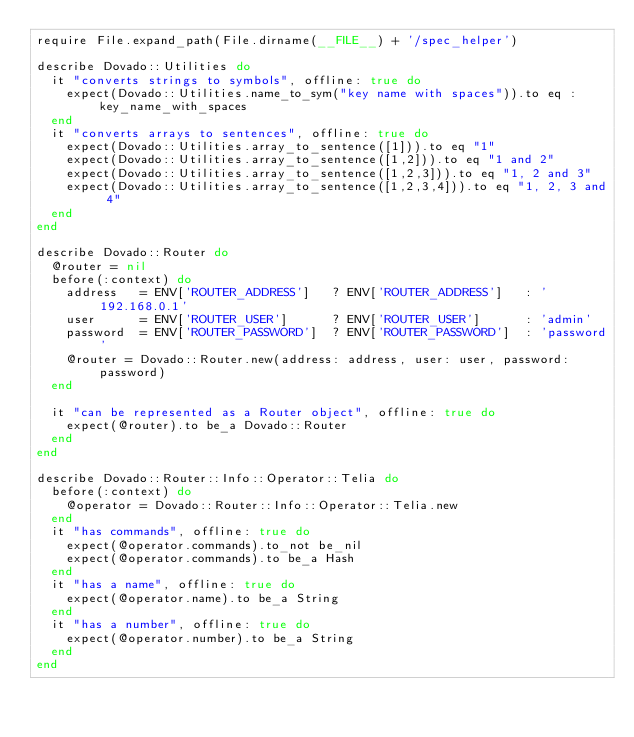Convert code to text. <code><loc_0><loc_0><loc_500><loc_500><_Ruby_>require File.expand_path(File.dirname(__FILE__) + '/spec_helper')

describe Dovado::Utilities do
  it "converts strings to symbols", offline: true do
    expect(Dovado::Utilities.name_to_sym("key name with spaces")).to eq :key_name_with_spaces
  end
  it "converts arrays to sentences", offline: true do
    expect(Dovado::Utilities.array_to_sentence([1])).to eq "1"
    expect(Dovado::Utilities.array_to_sentence([1,2])).to eq "1 and 2"
    expect(Dovado::Utilities.array_to_sentence([1,2,3])).to eq "1, 2 and 3"
    expect(Dovado::Utilities.array_to_sentence([1,2,3,4])).to eq "1, 2, 3 and 4"
  end
end

describe Dovado::Router do
  @router = nil
  before(:context) do
    address   = ENV['ROUTER_ADDRESS']   ? ENV['ROUTER_ADDRESS']   : '192.168.0.1'
    user      = ENV['ROUTER_USER']      ? ENV['ROUTER_USER']      : 'admin'
    password  = ENV['ROUTER_PASSWORD']  ? ENV['ROUTER_PASSWORD']  : 'password'
    @router = Dovado::Router.new(address: address, user: user, password: password)
  end

  it "can be represented as a Router object", offline: true do
    expect(@router).to be_a Dovado::Router
  end
end

describe Dovado::Router::Info::Operator::Telia do
  before(:context) do
    @operator = Dovado::Router::Info::Operator::Telia.new
  end
  it "has commands", offline: true do
    expect(@operator.commands).to_not be_nil
    expect(@operator.commands).to be_a Hash
  end
  it "has a name", offline: true do
    expect(@operator.name).to be_a String
  end
  it "has a number", offline: true do
    expect(@operator.number).to be_a String
  end
end</code> 